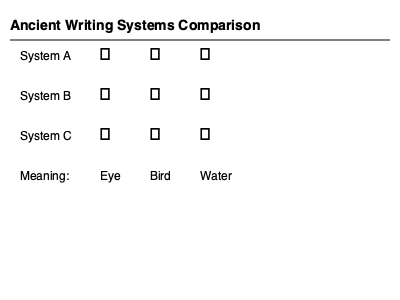Based on the comparison chart of ancient writing systems, which system appears to be the most pictographic, and how might this characteristic influence the decipherment process for an archaeologist studying newly discovered texts? To answer this question, we need to analyze the characteristics of each writing system presented in the chart and understand the implications for decipherment. Let's break it down step-by-step:

1. Examine System A:
   - The symbols (𓂀, 𓃀, 𓆣) are highly detailed and resemble the objects they represent.
   - The eye symbol (𓂀) clearly depicts an eye, the bird symbol (𓃀) resembles a bird, and the water symbol (𓆣) looks like wavy lines representing water.

2. Examine System B:
   - The symbols (𐎠, 𐎲, 𐏊) are more abstract and less pictorial.
   - They show some simplification but still retain some visual connection to their meanings.

3. Examine System C:
   - The symbols (𐤀, 𐤁, 𐤂) are the most abstract and show little resemblance to the objects they represent.
   - They appear to be more like arbitrary signs than pictures.

4. Compare the systems:
   - System A is the most pictographic, as its symbols clearly resemble the objects they represent.
   - System B is less pictographic than A but more so than C.
   - System C is the least pictographic, with highly abstracted symbols.

5. Consider the influence on the decipherment process:
   - Pictographic systems like System A can be easier to decipher initially because:
     a) The symbols visually represent their meanings, providing immediate clues.
     b) They often depict familiar objects, animals, or natural phenomena.
     c) They can be compared to known pictographic systems (e.g., Egyptian hieroglyphs) for potential connections.

   - However, pictographic systems can also present challenges:
     a) The meaning of more abstract concepts may be difficult to interpret from pictures alone.
     b) The system may have evolved over time, with symbols becoming more stylized and less recognizable.
     c) Cultural context is crucial for understanding specific depictions and their significance.

6. Implications for an archaeologist:
   - When studying newly discovered texts, an archaeologist would likely:
     a) Start by identifying recurring symbols and their potential meanings based on visual representation.
     b) Look for patterns in symbol usage and combinations to infer grammatical structures.
     c) Compare the symbols to known writing systems from similar cultures or time periods.
     d) Consider the cultural and historical context of the civilization that produced the texts.

In conclusion, System A appears to be the most pictographic, which can provide an initial advantage in decipherment due to the visual clues inherent in the symbols. However, the archaeologist must still approach the decipherment process systematically, considering various factors beyond just the visual appearance of the symbols.
Answer: System A; easier initial interpretation but requires careful contextual analysis. 